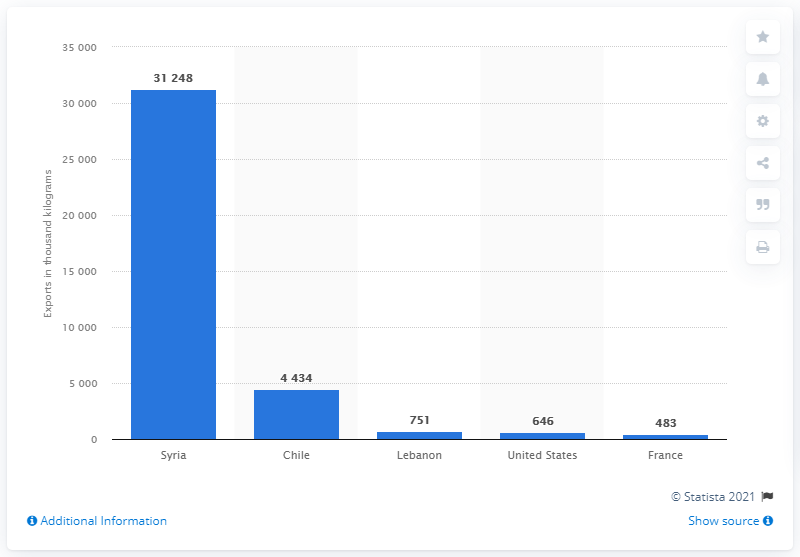List a handful of essential elements in this visual. In 2019, Syria was the main destination for Argentinian yerba mate exports. Chile was the second leading destination for yerba mate exports. 